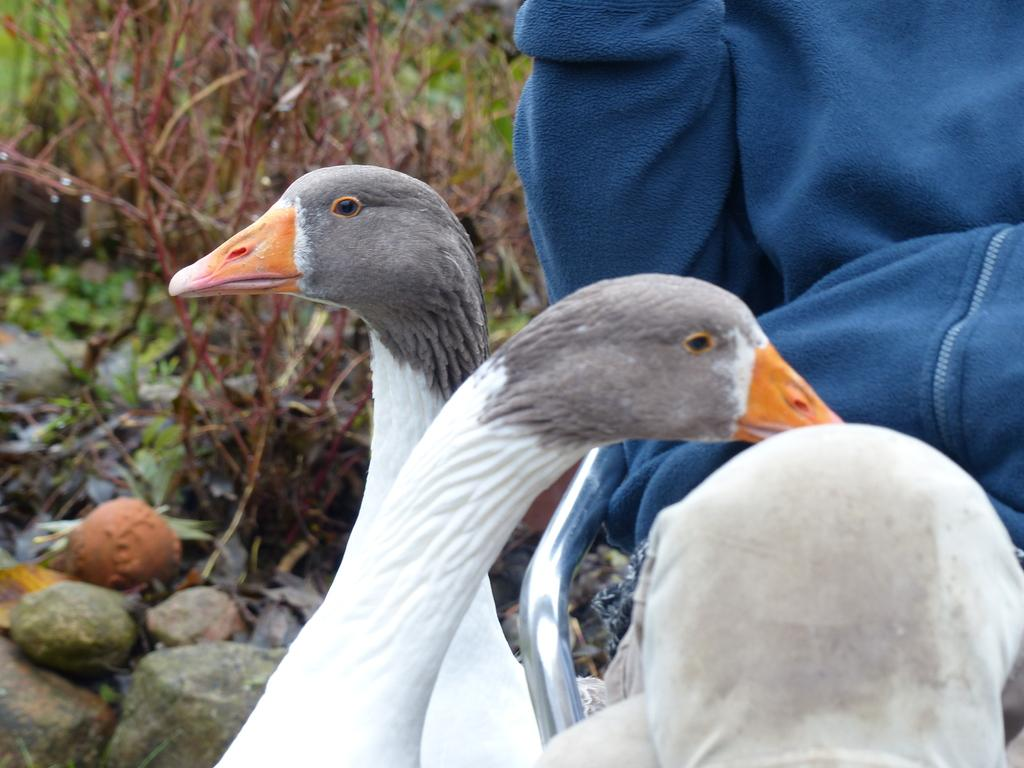What animals can be seen in the image? There are swans in the image. Who or what else is present in the image? There is a person in the image. What type of vegetation is visible in the image? There are plants in the image. What object can be seen in the image that is not a living organism? There is a rod in the image. What natural elements are present in the image? There are rocks in the image. What is the person wearing in the image? The person is wearing a jacket. What type of mist can be seen surrounding the swans in the image? There is no mist present in the image; it is a clear scene with swans, a person, plants, a rod, rocks, and a person wearing a jacket. Is there a hospital visible in the image? No, there is no hospital present in the image. 